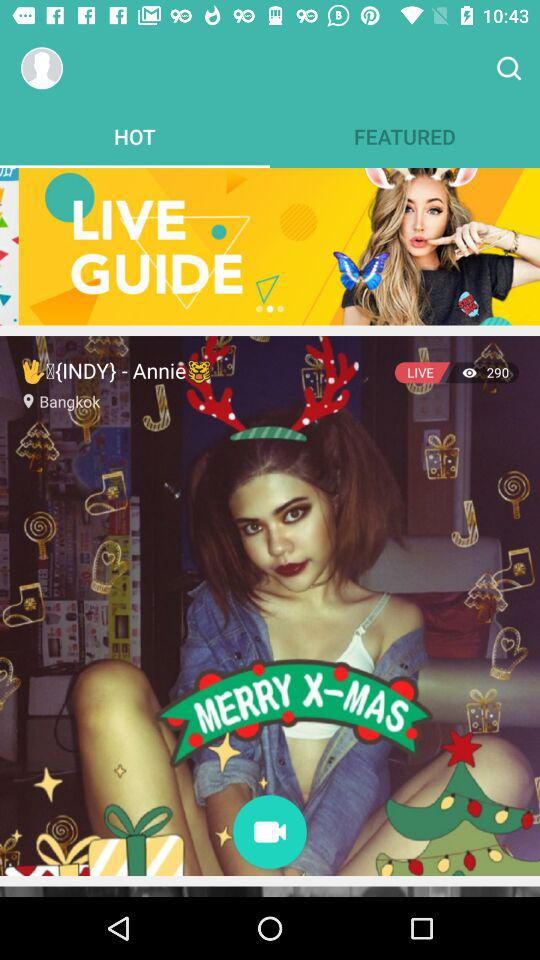How many users are watching live? The number of users watching live is 290. 